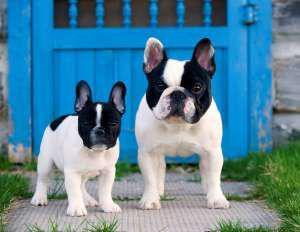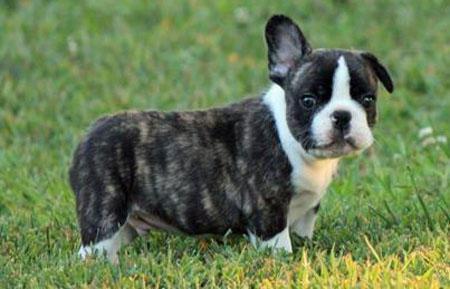The first image is the image on the left, the second image is the image on the right. Evaluate the accuracy of this statement regarding the images: "There are three dogs". Is it true? Answer yes or no. Yes. 